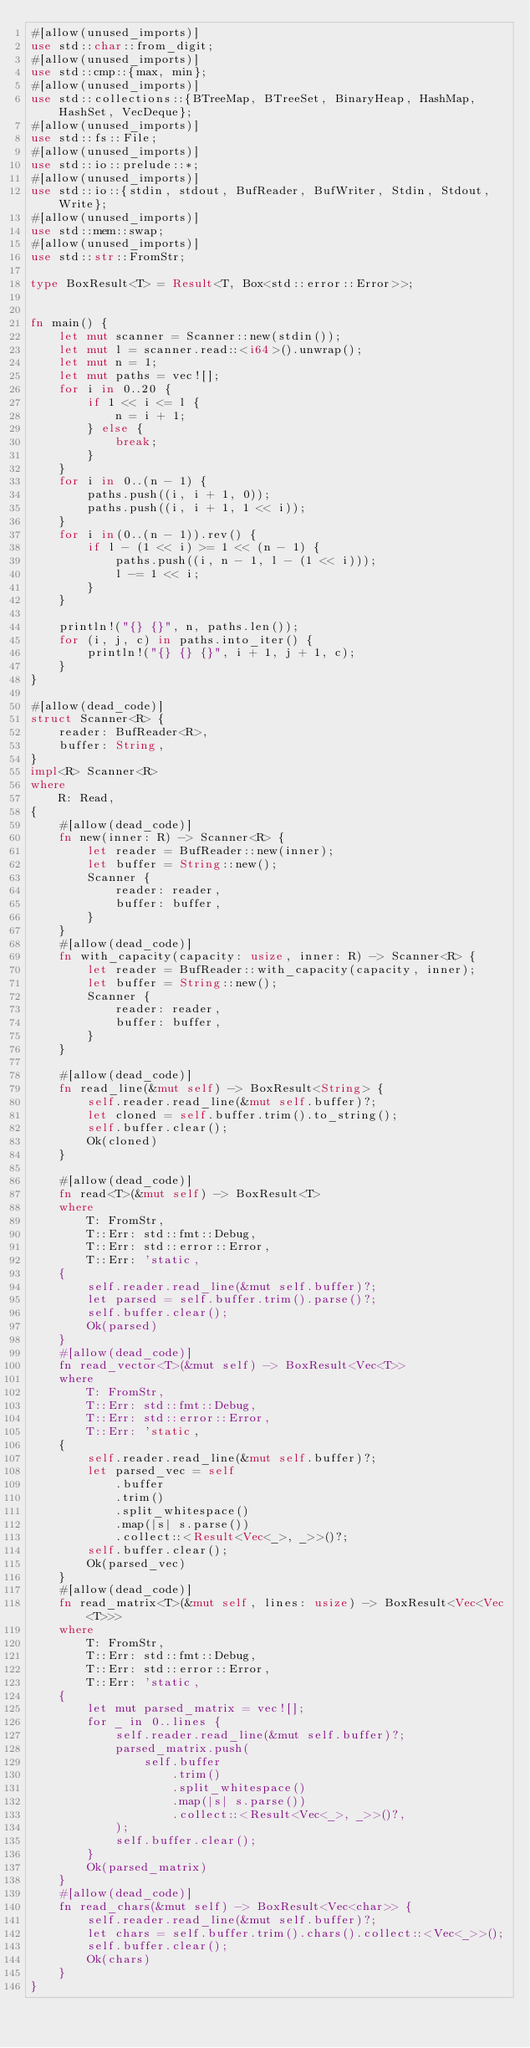Convert code to text. <code><loc_0><loc_0><loc_500><loc_500><_Rust_>#[allow(unused_imports)]
use std::char::from_digit;
#[allow(unused_imports)]
use std::cmp::{max, min};
#[allow(unused_imports)]
use std::collections::{BTreeMap, BTreeSet, BinaryHeap, HashMap, HashSet, VecDeque};
#[allow(unused_imports)]
use std::fs::File;
#[allow(unused_imports)]
use std::io::prelude::*;
#[allow(unused_imports)]
use std::io::{stdin, stdout, BufReader, BufWriter, Stdin, Stdout, Write};
#[allow(unused_imports)]
use std::mem::swap;
#[allow(unused_imports)]
use std::str::FromStr;

type BoxResult<T> = Result<T, Box<std::error::Error>>;


fn main() {
    let mut scanner = Scanner::new(stdin());
    let mut l = scanner.read::<i64>().unwrap();
    let mut n = 1;
    let mut paths = vec![];
    for i in 0..20 {
        if 1 << i <= l {
            n = i + 1;
        } else {
            break;
        }
    }
    for i in 0..(n - 1) {
        paths.push((i, i + 1, 0));
        paths.push((i, i + 1, 1 << i));
    }
    for i in(0..(n - 1)).rev() {
        if l - (1 << i) >= 1 << (n - 1) {
            paths.push((i, n - 1, l - (1 << i)));
            l -= 1 << i;
        }
    }

    println!("{} {}", n, paths.len());
    for (i, j, c) in paths.into_iter() {
        println!("{} {} {}", i + 1, j + 1, c);
    }
}

#[allow(dead_code)]
struct Scanner<R> {
    reader: BufReader<R>,
    buffer: String,
}
impl<R> Scanner<R>
where
    R: Read,
{
    #[allow(dead_code)]
    fn new(inner: R) -> Scanner<R> {
        let reader = BufReader::new(inner);
        let buffer = String::new();
        Scanner {
            reader: reader,
            buffer: buffer,
        }
    }
    #[allow(dead_code)]
    fn with_capacity(capacity: usize, inner: R) -> Scanner<R> {
        let reader = BufReader::with_capacity(capacity, inner);
        let buffer = String::new();
        Scanner {
            reader: reader,
            buffer: buffer,
        }
    }

    #[allow(dead_code)]
    fn read_line(&mut self) -> BoxResult<String> {
        self.reader.read_line(&mut self.buffer)?;
        let cloned = self.buffer.trim().to_string();
        self.buffer.clear();
        Ok(cloned)
    }

    #[allow(dead_code)]
    fn read<T>(&mut self) -> BoxResult<T>
    where
        T: FromStr,
        T::Err: std::fmt::Debug,
        T::Err: std::error::Error,
        T::Err: 'static,
    {
        self.reader.read_line(&mut self.buffer)?;
        let parsed = self.buffer.trim().parse()?;
        self.buffer.clear();
        Ok(parsed)
    }
    #[allow(dead_code)]
    fn read_vector<T>(&mut self) -> BoxResult<Vec<T>>
    where
        T: FromStr,
        T::Err: std::fmt::Debug,
        T::Err: std::error::Error,
        T::Err: 'static,
    {
        self.reader.read_line(&mut self.buffer)?;
        let parsed_vec = self
            .buffer
            .trim()
            .split_whitespace()
            .map(|s| s.parse())
            .collect::<Result<Vec<_>, _>>()?;
        self.buffer.clear();
        Ok(parsed_vec)
    }
    #[allow(dead_code)]
    fn read_matrix<T>(&mut self, lines: usize) -> BoxResult<Vec<Vec<T>>>
    where
        T: FromStr,
        T::Err: std::fmt::Debug,
        T::Err: std::error::Error,
        T::Err: 'static,
    {
        let mut parsed_matrix = vec![];
        for _ in 0..lines {
            self.reader.read_line(&mut self.buffer)?;
            parsed_matrix.push(
                self.buffer
                    .trim()
                    .split_whitespace()
                    .map(|s| s.parse())
                    .collect::<Result<Vec<_>, _>>()?,
            );
            self.buffer.clear();
        }
        Ok(parsed_matrix)
    }
    #[allow(dead_code)]
    fn read_chars(&mut self) -> BoxResult<Vec<char>> {
        self.reader.read_line(&mut self.buffer)?;
        let chars = self.buffer.trim().chars().collect::<Vec<_>>();
        self.buffer.clear();
        Ok(chars)
    }
}
</code> 